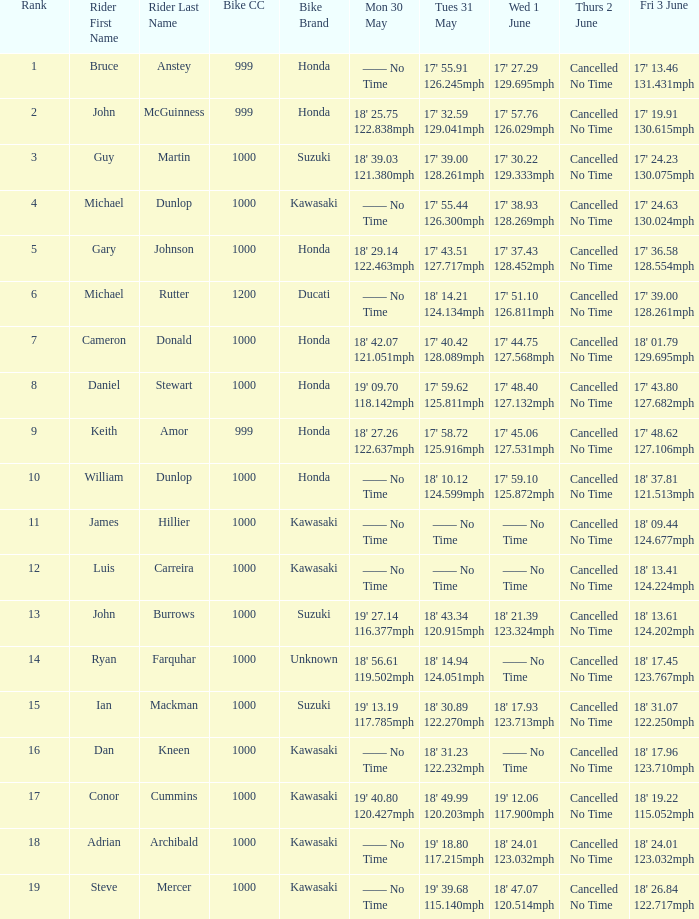What is the Thurs 2 June time for the rider with a Fri 3 June time of 17' 36.58 128.554mph? Cancelled No Time. 